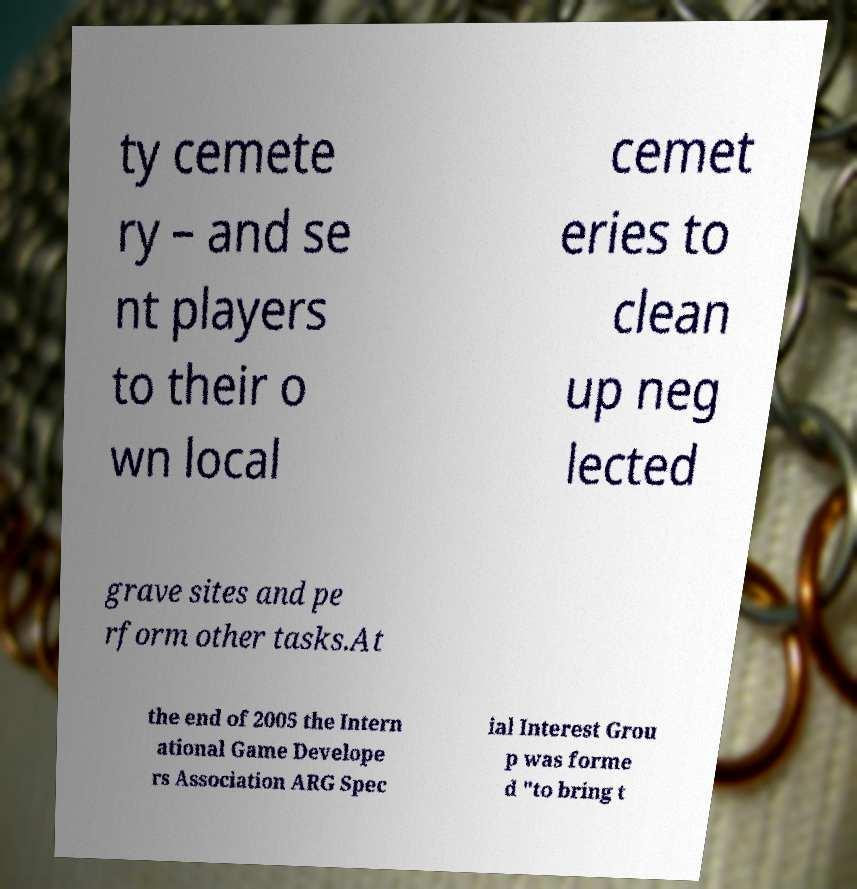There's text embedded in this image that I need extracted. Can you transcribe it verbatim? ty cemete ry – and se nt players to their o wn local cemet eries to clean up neg lected grave sites and pe rform other tasks.At the end of 2005 the Intern ational Game Develope rs Association ARG Spec ial Interest Grou p was forme d "to bring t 